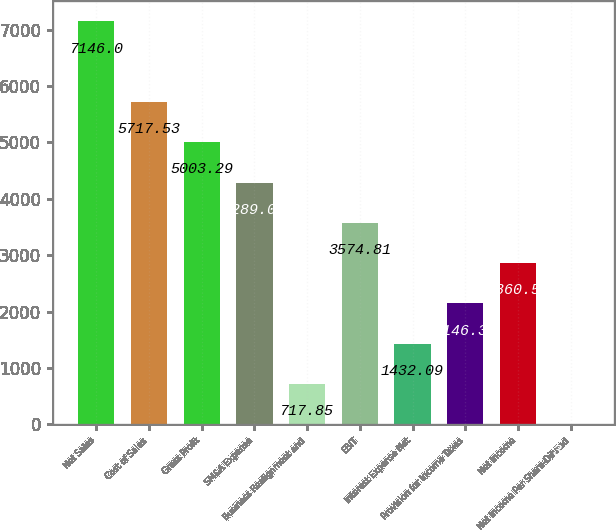Convert chart to OTSL. <chart><loc_0><loc_0><loc_500><loc_500><bar_chart><fcel>Net Sales<fcel>Cost of Sales<fcel>Gross Profit<fcel>SM&A Expense<fcel>Business Realignment and<fcel>EBIT<fcel>Interest Expense Net<fcel>Provision for Income Taxes<fcel>Net Income<fcel>Net Income Per Share-Diluted<nl><fcel>7146<fcel>5717.53<fcel>5003.29<fcel>4289.05<fcel>717.85<fcel>3574.81<fcel>1432.09<fcel>2146.33<fcel>2860.57<fcel>3.61<nl></chart> 